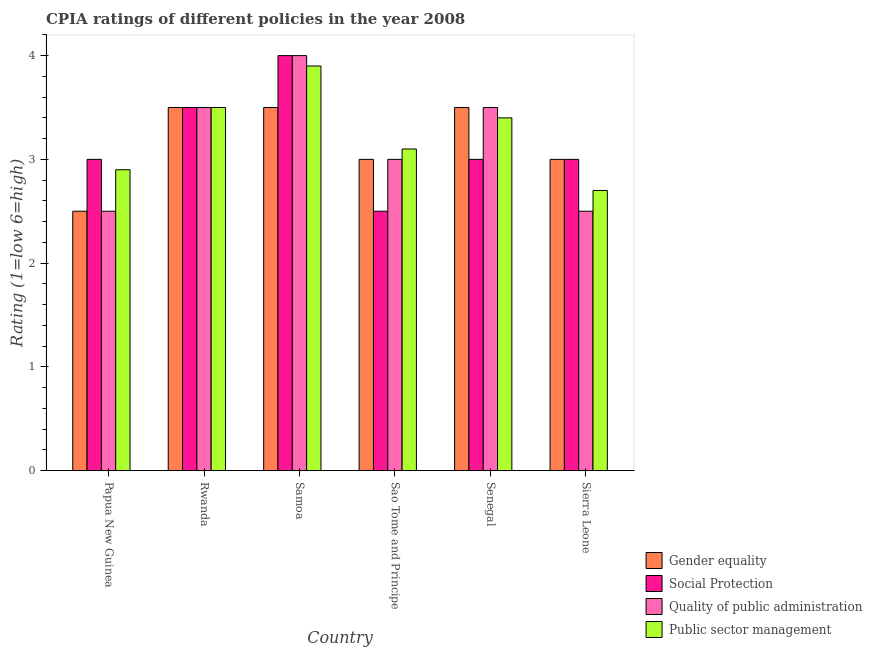How many groups of bars are there?
Make the answer very short. 6. Are the number of bars on each tick of the X-axis equal?
Keep it short and to the point. Yes. What is the label of the 3rd group of bars from the left?
Provide a succinct answer. Samoa. In how many cases, is the number of bars for a given country not equal to the number of legend labels?
Provide a short and direct response. 0. What is the cpia rating of public sector management in Samoa?
Offer a very short reply. 3.9. In which country was the cpia rating of quality of public administration maximum?
Your answer should be compact. Samoa. In which country was the cpia rating of social protection minimum?
Your response must be concise. Sao Tome and Principe. What is the difference between the cpia rating of gender equality in Rwanda and that in Sao Tome and Principe?
Keep it short and to the point. 0.5. What is the difference between the cpia rating of social protection in Sierra Leone and the cpia rating of public sector management in Papua New Guinea?
Keep it short and to the point. 0.1. What is the average cpia rating of quality of public administration per country?
Ensure brevity in your answer.  3.17. In how many countries, is the cpia rating of public sector management greater than 3.6 ?
Ensure brevity in your answer.  1. What is the ratio of the cpia rating of public sector management in Sao Tome and Principe to that in Senegal?
Ensure brevity in your answer.  0.91. Is the cpia rating of quality of public administration in Papua New Guinea less than that in Sierra Leone?
Make the answer very short. No. What is the difference between the highest and the second highest cpia rating of quality of public administration?
Give a very brief answer. 0.5. What is the difference between the highest and the lowest cpia rating of social protection?
Provide a short and direct response. 1.5. Is the sum of the cpia rating of gender equality in Rwanda and Senegal greater than the maximum cpia rating of social protection across all countries?
Give a very brief answer. Yes. What does the 3rd bar from the left in Senegal represents?
Provide a succinct answer. Quality of public administration. What does the 3rd bar from the right in Sierra Leone represents?
Your response must be concise. Social Protection. Are all the bars in the graph horizontal?
Give a very brief answer. No. How many countries are there in the graph?
Offer a very short reply. 6. How many legend labels are there?
Give a very brief answer. 4. How are the legend labels stacked?
Make the answer very short. Vertical. What is the title of the graph?
Offer a terse response. CPIA ratings of different policies in the year 2008. What is the label or title of the Y-axis?
Ensure brevity in your answer.  Rating (1=low 6=high). What is the Rating (1=low 6=high) of Gender equality in Papua New Guinea?
Give a very brief answer. 2.5. What is the Rating (1=low 6=high) in Public sector management in Papua New Guinea?
Your response must be concise. 2.9. What is the Rating (1=low 6=high) of Gender equality in Rwanda?
Give a very brief answer. 3.5. What is the Rating (1=low 6=high) in Social Protection in Rwanda?
Give a very brief answer. 3.5. What is the Rating (1=low 6=high) in Gender equality in Samoa?
Provide a succinct answer. 3.5. What is the Rating (1=low 6=high) of Social Protection in Samoa?
Give a very brief answer. 4. What is the Rating (1=low 6=high) of Quality of public administration in Samoa?
Ensure brevity in your answer.  4. What is the Rating (1=low 6=high) in Social Protection in Sao Tome and Principe?
Offer a terse response. 2.5. What is the Rating (1=low 6=high) of Quality of public administration in Senegal?
Provide a succinct answer. 3.5. What is the Rating (1=low 6=high) in Gender equality in Sierra Leone?
Provide a succinct answer. 3. What is the Rating (1=low 6=high) of Social Protection in Sierra Leone?
Give a very brief answer. 3. What is the Rating (1=low 6=high) of Quality of public administration in Sierra Leone?
Your answer should be compact. 2.5. What is the Rating (1=low 6=high) of Public sector management in Sierra Leone?
Offer a terse response. 2.7. Across all countries, what is the maximum Rating (1=low 6=high) of Gender equality?
Keep it short and to the point. 3.5. Across all countries, what is the maximum Rating (1=low 6=high) in Social Protection?
Your response must be concise. 4. Across all countries, what is the maximum Rating (1=low 6=high) of Quality of public administration?
Ensure brevity in your answer.  4. What is the total Rating (1=low 6=high) of Quality of public administration in the graph?
Provide a succinct answer. 19. What is the difference between the Rating (1=low 6=high) of Gender equality in Papua New Guinea and that in Rwanda?
Your answer should be very brief. -1. What is the difference between the Rating (1=low 6=high) of Social Protection in Papua New Guinea and that in Rwanda?
Offer a terse response. -0.5. What is the difference between the Rating (1=low 6=high) in Quality of public administration in Papua New Guinea and that in Rwanda?
Provide a short and direct response. -1. What is the difference between the Rating (1=low 6=high) in Public sector management in Papua New Guinea and that in Rwanda?
Give a very brief answer. -0.6. What is the difference between the Rating (1=low 6=high) in Public sector management in Papua New Guinea and that in Samoa?
Your answer should be compact. -1. What is the difference between the Rating (1=low 6=high) in Public sector management in Papua New Guinea and that in Sao Tome and Principe?
Make the answer very short. -0.2. What is the difference between the Rating (1=low 6=high) in Gender equality in Papua New Guinea and that in Senegal?
Your answer should be very brief. -1. What is the difference between the Rating (1=low 6=high) of Quality of public administration in Papua New Guinea and that in Senegal?
Give a very brief answer. -1. What is the difference between the Rating (1=low 6=high) of Public sector management in Papua New Guinea and that in Senegal?
Offer a terse response. -0.5. What is the difference between the Rating (1=low 6=high) in Gender equality in Papua New Guinea and that in Sierra Leone?
Ensure brevity in your answer.  -0.5. What is the difference between the Rating (1=low 6=high) in Social Protection in Papua New Guinea and that in Sierra Leone?
Make the answer very short. 0. What is the difference between the Rating (1=low 6=high) in Quality of public administration in Papua New Guinea and that in Sierra Leone?
Keep it short and to the point. 0. What is the difference between the Rating (1=low 6=high) of Public sector management in Papua New Guinea and that in Sierra Leone?
Your answer should be compact. 0.2. What is the difference between the Rating (1=low 6=high) of Gender equality in Rwanda and that in Samoa?
Your response must be concise. 0. What is the difference between the Rating (1=low 6=high) of Social Protection in Rwanda and that in Sao Tome and Principe?
Your answer should be compact. 1. What is the difference between the Rating (1=low 6=high) in Public sector management in Rwanda and that in Sao Tome and Principe?
Your answer should be very brief. 0.4. What is the difference between the Rating (1=low 6=high) in Gender equality in Rwanda and that in Senegal?
Provide a succinct answer. 0. What is the difference between the Rating (1=low 6=high) of Social Protection in Rwanda and that in Senegal?
Provide a short and direct response. 0.5. What is the difference between the Rating (1=low 6=high) in Quality of public administration in Rwanda and that in Senegal?
Keep it short and to the point. 0. What is the difference between the Rating (1=low 6=high) of Gender equality in Rwanda and that in Sierra Leone?
Make the answer very short. 0.5. What is the difference between the Rating (1=low 6=high) of Social Protection in Rwanda and that in Sierra Leone?
Offer a terse response. 0.5. What is the difference between the Rating (1=low 6=high) of Quality of public administration in Rwanda and that in Sierra Leone?
Ensure brevity in your answer.  1. What is the difference between the Rating (1=low 6=high) of Social Protection in Samoa and that in Sao Tome and Principe?
Make the answer very short. 1.5. What is the difference between the Rating (1=low 6=high) of Quality of public administration in Samoa and that in Sao Tome and Principe?
Provide a short and direct response. 1. What is the difference between the Rating (1=low 6=high) of Quality of public administration in Samoa and that in Senegal?
Give a very brief answer. 0.5. What is the difference between the Rating (1=low 6=high) in Public sector management in Samoa and that in Senegal?
Provide a short and direct response. 0.5. What is the difference between the Rating (1=low 6=high) of Gender equality in Samoa and that in Sierra Leone?
Offer a terse response. 0.5. What is the difference between the Rating (1=low 6=high) in Social Protection in Samoa and that in Sierra Leone?
Your response must be concise. 1. What is the difference between the Rating (1=low 6=high) of Quality of public administration in Samoa and that in Sierra Leone?
Ensure brevity in your answer.  1.5. What is the difference between the Rating (1=low 6=high) of Gender equality in Sao Tome and Principe and that in Senegal?
Give a very brief answer. -0.5. What is the difference between the Rating (1=low 6=high) in Social Protection in Sao Tome and Principe and that in Senegal?
Provide a short and direct response. -0.5. What is the difference between the Rating (1=low 6=high) of Quality of public administration in Sao Tome and Principe and that in Senegal?
Offer a terse response. -0.5. What is the difference between the Rating (1=low 6=high) of Gender equality in Sao Tome and Principe and that in Sierra Leone?
Keep it short and to the point. 0. What is the difference between the Rating (1=low 6=high) in Quality of public administration in Sao Tome and Principe and that in Sierra Leone?
Offer a very short reply. 0.5. What is the difference between the Rating (1=low 6=high) of Public sector management in Sao Tome and Principe and that in Sierra Leone?
Ensure brevity in your answer.  0.4. What is the difference between the Rating (1=low 6=high) in Gender equality in Senegal and that in Sierra Leone?
Offer a very short reply. 0.5. What is the difference between the Rating (1=low 6=high) in Public sector management in Senegal and that in Sierra Leone?
Your response must be concise. 0.7. What is the difference between the Rating (1=low 6=high) in Gender equality in Papua New Guinea and the Rating (1=low 6=high) in Social Protection in Rwanda?
Your answer should be compact. -1. What is the difference between the Rating (1=low 6=high) of Gender equality in Papua New Guinea and the Rating (1=low 6=high) of Quality of public administration in Rwanda?
Provide a short and direct response. -1. What is the difference between the Rating (1=low 6=high) of Social Protection in Papua New Guinea and the Rating (1=low 6=high) of Public sector management in Rwanda?
Ensure brevity in your answer.  -0.5. What is the difference between the Rating (1=low 6=high) in Quality of public administration in Papua New Guinea and the Rating (1=low 6=high) in Public sector management in Rwanda?
Provide a succinct answer. -1. What is the difference between the Rating (1=low 6=high) of Gender equality in Papua New Guinea and the Rating (1=low 6=high) of Quality of public administration in Samoa?
Your answer should be compact. -1.5. What is the difference between the Rating (1=low 6=high) in Social Protection in Papua New Guinea and the Rating (1=low 6=high) in Quality of public administration in Samoa?
Ensure brevity in your answer.  -1. What is the difference between the Rating (1=low 6=high) in Gender equality in Papua New Guinea and the Rating (1=low 6=high) in Social Protection in Sao Tome and Principe?
Offer a terse response. 0. What is the difference between the Rating (1=low 6=high) in Quality of public administration in Papua New Guinea and the Rating (1=low 6=high) in Public sector management in Sao Tome and Principe?
Provide a short and direct response. -0.6. What is the difference between the Rating (1=low 6=high) of Gender equality in Papua New Guinea and the Rating (1=low 6=high) of Social Protection in Senegal?
Offer a terse response. -0.5. What is the difference between the Rating (1=low 6=high) of Gender equality in Papua New Guinea and the Rating (1=low 6=high) of Public sector management in Senegal?
Give a very brief answer. -0.9. What is the difference between the Rating (1=low 6=high) of Social Protection in Papua New Guinea and the Rating (1=low 6=high) of Quality of public administration in Senegal?
Offer a very short reply. -0.5. What is the difference between the Rating (1=low 6=high) in Social Protection in Papua New Guinea and the Rating (1=low 6=high) in Public sector management in Senegal?
Provide a short and direct response. -0.4. What is the difference between the Rating (1=low 6=high) of Quality of public administration in Papua New Guinea and the Rating (1=low 6=high) of Public sector management in Senegal?
Give a very brief answer. -0.9. What is the difference between the Rating (1=low 6=high) in Gender equality in Papua New Guinea and the Rating (1=low 6=high) in Public sector management in Sierra Leone?
Keep it short and to the point. -0.2. What is the difference between the Rating (1=low 6=high) of Social Protection in Papua New Guinea and the Rating (1=low 6=high) of Public sector management in Sierra Leone?
Give a very brief answer. 0.3. What is the difference between the Rating (1=low 6=high) in Gender equality in Rwanda and the Rating (1=low 6=high) in Social Protection in Samoa?
Your answer should be compact. -0.5. What is the difference between the Rating (1=low 6=high) of Social Protection in Rwanda and the Rating (1=low 6=high) of Quality of public administration in Samoa?
Provide a short and direct response. -0.5. What is the difference between the Rating (1=low 6=high) of Social Protection in Rwanda and the Rating (1=low 6=high) of Public sector management in Samoa?
Your response must be concise. -0.4. What is the difference between the Rating (1=low 6=high) in Quality of public administration in Rwanda and the Rating (1=low 6=high) in Public sector management in Samoa?
Your answer should be very brief. -0.4. What is the difference between the Rating (1=low 6=high) in Gender equality in Rwanda and the Rating (1=low 6=high) in Social Protection in Sao Tome and Principe?
Give a very brief answer. 1. What is the difference between the Rating (1=low 6=high) of Gender equality in Rwanda and the Rating (1=low 6=high) of Quality of public administration in Sao Tome and Principe?
Provide a short and direct response. 0.5. What is the difference between the Rating (1=low 6=high) in Quality of public administration in Rwanda and the Rating (1=low 6=high) in Public sector management in Sao Tome and Principe?
Make the answer very short. 0.4. What is the difference between the Rating (1=low 6=high) of Gender equality in Rwanda and the Rating (1=low 6=high) of Social Protection in Senegal?
Provide a short and direct response. 0.5. What is the difference between the Rating (1=low 6=high) of Gender equality in Rwanda and the Rating (1=low 6=high) of Quality of public administration in Senegal?
Keep it short and to the point. 0. What is the difference between the Rating (1=low 6=high) of Gender equality in Rwanda and the Rating (1=low 6=high) of Public sector management in Senegal?
Provide a short and direct response. 0.1. What is the difference between the Rating (1=low 6=high) of Social Protection in Rwanda and the Rating (1=low 6=high) of Quality of public administration in Senegal?
Make the answer very short. 0. What is the difference between the Rating (1=low 6=high) of Social Protection in Rwanda and the Rating (1=low 6=high) of Public sector management in Senegal?
Offer a very short reply. 0.1. What is the difference between the Rating (1=low 6=high) of Quality of public administration in Rwanda and the Rating (1=low 6=high) of Public sector management in Senegal?
Ensure brevity in your answer.  0.1. What is the difference between the Rating (1=low 6=high) in Gender equality in Rwanda and the Rating (1=low 6=high) in Social Protection in Sierra Leone?
Offer a terse response. 0.5. What is the difference between the Rating (1=low 6=high) of Gender equality in Rwanda and the Rating (1=low 6=high) of Quality of public administration in Sierra Leone?
Provide a succinct answer. 1. What is the difference between the Rating (1=low 6=high) in Gender equality in Rwanda and the Rating (1=low 6=high) in Public sector management in Sierra Leone?
Offer a terse response. 0.8. What is the difference between the Rating (1=low 6=high) of Quality of public administration in Rwanda and the Rating (1=low 6=high) of Public sector management in Sierra Leone?
Provide a succinct answer. 0.8. What is the difference between the Rating (1=low 6=high) in Gender equality in Samoa and the Rating (1=low 6=high) in Social Protection in Sao Tome and Principe?
Offer a terse response. 1. What is the difference between the Rating (1=low 6=high) in Gender equality in Samoa and the Rating (1=low 6=high) in Quality of public administration in Sao Tome and Principe?
Keep it short and to the point. 0.5. What is the difference between the Rating (1=low 6=high) of Gender equality in Samoa and the Rating (1=low 6=high) of Public sector management in Sao Tome and Principe?
Ensure brevity in your answer.  0.4. What is the difference between the Rating (1=low 6=high) in Social Protection in Samoa and the Rating (1=low 6=high) in Quality of public administration in Sao Tome and Principe?
Offer a very short reply. 1. What is the difference between the Rating (1=low 6=high) in Social Protection in Samoa and the Rating (1=low 6=high) in Public sector management in Senegal?
Give a very brief answer. 0.6. What is the difference between the Rating (1=low 6=high) in Quality of public administration in Samoa and the Rating (1=low 6=high) in Public sector management in Senegal?
Provide a short and direct response. 0.6. What is the difference between the Rating (1=low 6=high) in Social Protection in Samoa and the Rating (1=low 6=high) in Quality of public administration in Sierra Leone?
Make the answer very short. 1.5. What is the difference between the Rating (1=low 6=high) in Quality of public administration in Samoa and the Rating (1=low 6=high) in Public sector management in Sierra Leone?
Keep it short and to the point. 1.3. What is the difference between the Rating (1=low 6=high) in Gender equality in Sao Tome and Principe and the Rating (1=low 6=high) in Public sector management in Senegal?
Offer a terse response. -0.4. What is the difference between the Rating (1=low 6=high) in Social Protection in Sao Tome and Principe and the Rating (1=low 6=high) in Quality of public administration in Senegal?
Make the answer very short. -1. What is the difference between the Rating (1=low 6=high) of Gender equality in Sao Tome and Principe and the Rating (1=low 6=high) of Public sector management in Sierra Leone?
Give a very brief answer. 0.3. What is the difference between the Rating (1=low 6=high) of Social Protection in Sao Tome and Principe and the Rating (1=low 6=high) of Quality of public administration in Sierra Leone?
Give a very brief answer. 0. What is the difference between the Rating (1=low 6=high) in Gender equality in Senegal and the Rating (1=low 6=high) in Public sector management in Sierra Leone?
Ensure brevity in your answer.  0.8. What is the difference between the Rating (1=low 6=high) in Social Protection in Senegal and the Rating (1=low 6=high) in Quality of public administration in Sierra Leone?
Make the answer very short. 0.5. What is the average Rating (1=low 6=high) of Gender equality per country?
Ensure brevity in your answer.  3.17. What is the average Rating (1=low 6=high) of Social Protection per country?
Provide a succinct answer. 3.17. What is the average Rating (1=low 6=high) of Quality of public administration per country?
Make the answer very short. 3.17. What is the average Rating (1=low 6=high) in Public sector management per country?
Offer a terse response. 3.25. What is the difference between the Rating (1=low 6=high) of Gender equality and Rating (1=low 6=high) of Social Protection in Papua New Guinea?
Provide a short and direct response. -0.5. What is the difference between the Rating (1=low 6=high) of Social Protection and Rating (1=low 6=high) of Public sector management in Papua New Guinea?
Provide a short and direct response. 0.1. What is the difference between the Rating (1=low 6=high) in Quality of public administration and Rating (1=low 6=high) in Public sector management in Papua New Guinea?
Make the answer very short. -0.4. What is the difference between the Rating (1=low 6=high) of Gender equality and Rating (1=low 6=high) of Social Protection in Rwanda?
Your response must be concise. 0. What is the difference between the Rating (1=low 6=high) in Gender equality and Rating (1=low 6=high) in Quality of public administration in Rwanda?
Provide a short and direct response. 0. What is the difference between the Rating (1=low 6=high) in Gender equality and Rating (1=low 6=high) in Public sector management in Rwanda?
Ensure brevity in your answer.  0. What is the difference between the Rating (1=low 6=high) in Social Protection and Rating (1=low 6=high) in Public sector management in Rwanda?
Keep it short and to the point. 0. What is the difference between the Rating (1=low 6=high) of Gender equality and Rating (1=low 6=high) of Social Protection in Samoa?
Ensure brevity in your answer.  -0.5. What is the difference between the Rating (1=low 6=high) of Gender equality and Rating (1=low 6=high) of Quality of public administration in Samoa?
Make the answer very short. -0.5. What is the difference between the Rating (1=low 6=high) in Social Protection and Rating (1=low 6=high) in Public sector management in Samoa?
Your answer should be compact. 0.1. What is the difference between the Rating (1=low 6=high) of Quality of public administration and Rating (1=low 6=high) of Public sector management in Samoa?
Give a very brief answer. 0.1. What is the difference between the Rating (1=low 6=high) of Gender equality and Rating (1=low 6=high) of Public sector management in Sao Tome and Principe?
Offer a terse response. -0.1. What is the difference between the Rating (1=low 6=high) in Social Protection and Rating (1=low 6=high) in Public sector management in Sao Tome and Principe?
Ensure brevity in your answer.  -0.6. What is the difference between the Rating (1=low 6=high) in Gender equality and Rating (1=low 6=high) in Social Protection in Senegal?
Provide a short and direct response. 0.5. What is the difference between the Rating (1=low 6=high) of Gender equality and Rating (1=low 6=high) of Quality of public administration in Senegal?
Provide a succinct answer. 0. What is the difference between the Rating (1=low 6=high) of Gender equality and Rating (1=low 6=high) of Public sector management in Senegal?
Give a very brief answer. 0.1. What is the difference between the Rating (1=low 6=high) in Gender equality and Rating (1=low 6=high) in Social Protection in Sierra Leone?
Offer a very short reply. 0. What is the difference between the Rating (1=low 6=high) in Gender equality and Rating (1=low 6=high) in Public sector management in Sierra Leone?
Keep it short and to the point. 0.3. What is the difference between the Rating (1=low 6=high) in Quality of public administration and Rating (1=low 6=high) in Public sector management in Sierra Leone?
Keep it short and to the point. -0.2. What is the ratio of the Rating (1=low 6=high) of Quality of public administration in Papua New Guinea to that in Rwanda?
Offer a very short reply. 0.71. What is the ratio of the Rating (1=low 6=high) of Public sector management in Papua New Guinea to that in Rwanda?
Provide a succinct answer. 0.83. What is the ratio of the Rating (1=low 6=high) in Quality of public administration in Papua New Guinea to that in Samoa?
Provide a succinct answer. 0.62. What is the ratio of the Rating (1=low 6=high) of Public sector management in Papua New Guinea to that in Samoa?
Offer a terse response. 0.74. What is the ratio of the Rating (1=low 6=high) of Gender equality in Papua New Guinea to that in Sao Tome and Principe?
Your response must be concise. 0.83. What is the ratio of the Rating (1=low 6=high) in Social Protection in Papua New Guinea to that in Sao Tome and Principe?
Offer a very short reply. 1.2. What is the ratio of the Rating (1=low 6=high) in Quality of public administration in Papua New Guinea to that in Sao Tome and Principe?
Your response must be concise. 0.83. What is the ratio of the Rating (1=low 6=high) in Public sector management in Papua New Guinea to that in Sao Tome and Principe?
Your answer should be very brief. 0.94. What is the ratio of the Rating (1=low 6=high) in Gender equality in Papua New Guinea to that in Senegal?
Provide a short and direct response. 0.71. What is the ratio of the Rating (1=low 6=high) of Social Protection in Papua New Guinea to that in Senegal?
Provide a succinct answer. 1. What is the ratio of the Rating (1=low 6=high) in Public sector management in Papua New Guinea to that in Senegal?
Ensure brevity in your answer.  0.85. What is the ratio of the Rating (1=low 6=high) of Gender equality in Papua New Guinea to that in Sierra Leone?
Your answer should be compact. 0.83. What is the ratio of the Rating (1=low 6=high) in Public sector management in Papua New Guinea to that in Sierra Leone?
Give a very brief answer. 1.07. What is the ratio of the Rating (1=low 6=high) in Social Protection in Rwanda to that in Samoa?
Ensure brevity in your answer.  0.88. What is the ratio of the Rating (1=low 6=high) in Quality of public administration in Rwanda to that in Samoa?
Your answer should be very brief. 0.88. What is the ratio of the Rating (1=low 6=high) in Public sector management in Rwanda to that in Samoa?
Keep it short and to the point. 0.9. What is the ratio of the Rating (1=low 6=high) in Social Protection in Rwanda to that in Sao Tome and Principe?
Your answer should be very brief. 1.4. What is the ratio of the Rating (1=low 6=high) of Public sector management in Rwanda to that in Sao Tome and Principe?
Make the answer very short. 1.13. What is the ratio of the Rating (1=low 6=high) of Social Protection in Rwanda to that in Senegal?
Offer a very short reply. 1.17. What is the ratio of the Rating (1=low 6=high) of Public sector management in Rwanda to that in Senegal?
Offer a very short reply. 1.03. What is the ratio of the Rating (1=low 6=high) of Gender equality in Rwanda to that in Sierra Leone?
Offer a very short reply. 1.17. What is the ratio of the Rating (1=low 6=high) in Public sector management in Rwanda to that in Sierra Leone?
Your response must be concise. 1.3. What is the ratio of the Rating (1=low 6=high) in Social Protection in Samoa to that in Sao Tome and Principe?
Keep it short and to the point. 1.6. What is the ratio of the Rating (1=low 6=high) in Quality of public administration in Samoa to that in Sao Tome and Principe?
Provide a succinct answer. 1.33. What is the ratio of the Rating (1=low 6=high) of Public sector management in Samoa to that in Sao Tome and Principe?
Provide a short and direct response. 1.26. What is the ratio of the Rating (1=low 6=high) in Gender equality in Samoa to that in Senegal?
Give a very brief answer. 1. What is the ratio of the Rating (1=low 6=high) in Public sector management in Samoa to that in Senegal?
Ensure brevity in your answer.  1.15. What is the ratio of the Rating (1=low 6=high) in Public sector management in Samoa to that in Sierra Leone?
Offer a terse response. 1.44. What is the ratio of the Rating (1=low 6=high) of Social Protection in Sao Tome and Principe to that in Senegal?
Your response must be concise. 0.83. What is the ratio of the Rating (1=low 6=high) in Quality of public administration in Sao Tome and Principe to that in Senegal?
Your answer should be compact. 0.86. What is the ratio of the Rating (1=low 6=high) of Public sector management in Sao Tome and Principe to that in Senegal?
Your response must be concise. 0.91. What is the ratio of the Rating (1=low 6=high) of Gender equality in Sao Tome and Principe to that in Sierra Leone?
Provide a short and direct response. 1. What is the ratio of the Rating (1=low 6=high) of Public sector management in Sao Tome and Principe to that in Sierra Leone?
Make the answer very short. 1.15. What is the ratio of the Rating (1=low 6=high) of Social Protection in Senegal to that in Sierra Leone?
Your answer should be very brief. 1. What is the ratio of the Rating (1=low 6=high) of Public sector management in Senegal to that in Sierra Leone?
Keep it short and to the point. 1.26. What is the difference between the highest and the second highest Rating (1=low 6=high) in Social Protection?
Give a very brief answer. 0.5. What is the difference between the highest and the second highest Rating (1=low 6=high) of Quality of public administration?
Your response must be concise. 0.5. What is the difference between the highest and the lowest Rating (1=low 6=high) of Gender equality?
Your answer should be compact. 1. What is the difference between the highest and the lowest Rating (1=low 6=high) in Public sector management?
Your answer should be compact. 1.2. 